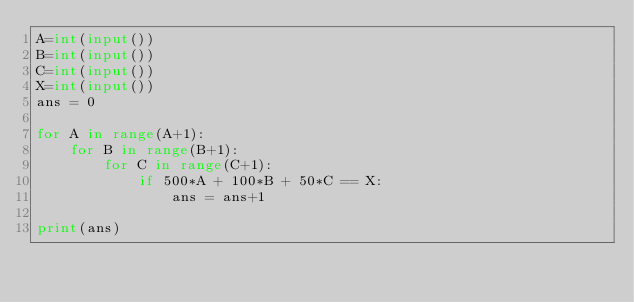Convert code to text. <code><loc_0><loc_0><loc_500><loc_500><_Python_>A=int(input())
B=int(input())
C=int(input())
X=int(input())
ans = 0

for A in range(A+1):
    for B in range(B+1):
        for C in range(C+1):
            if 500*A + 100*B + 50*C == X:
                ans = ans+1

print(ans)</code> 